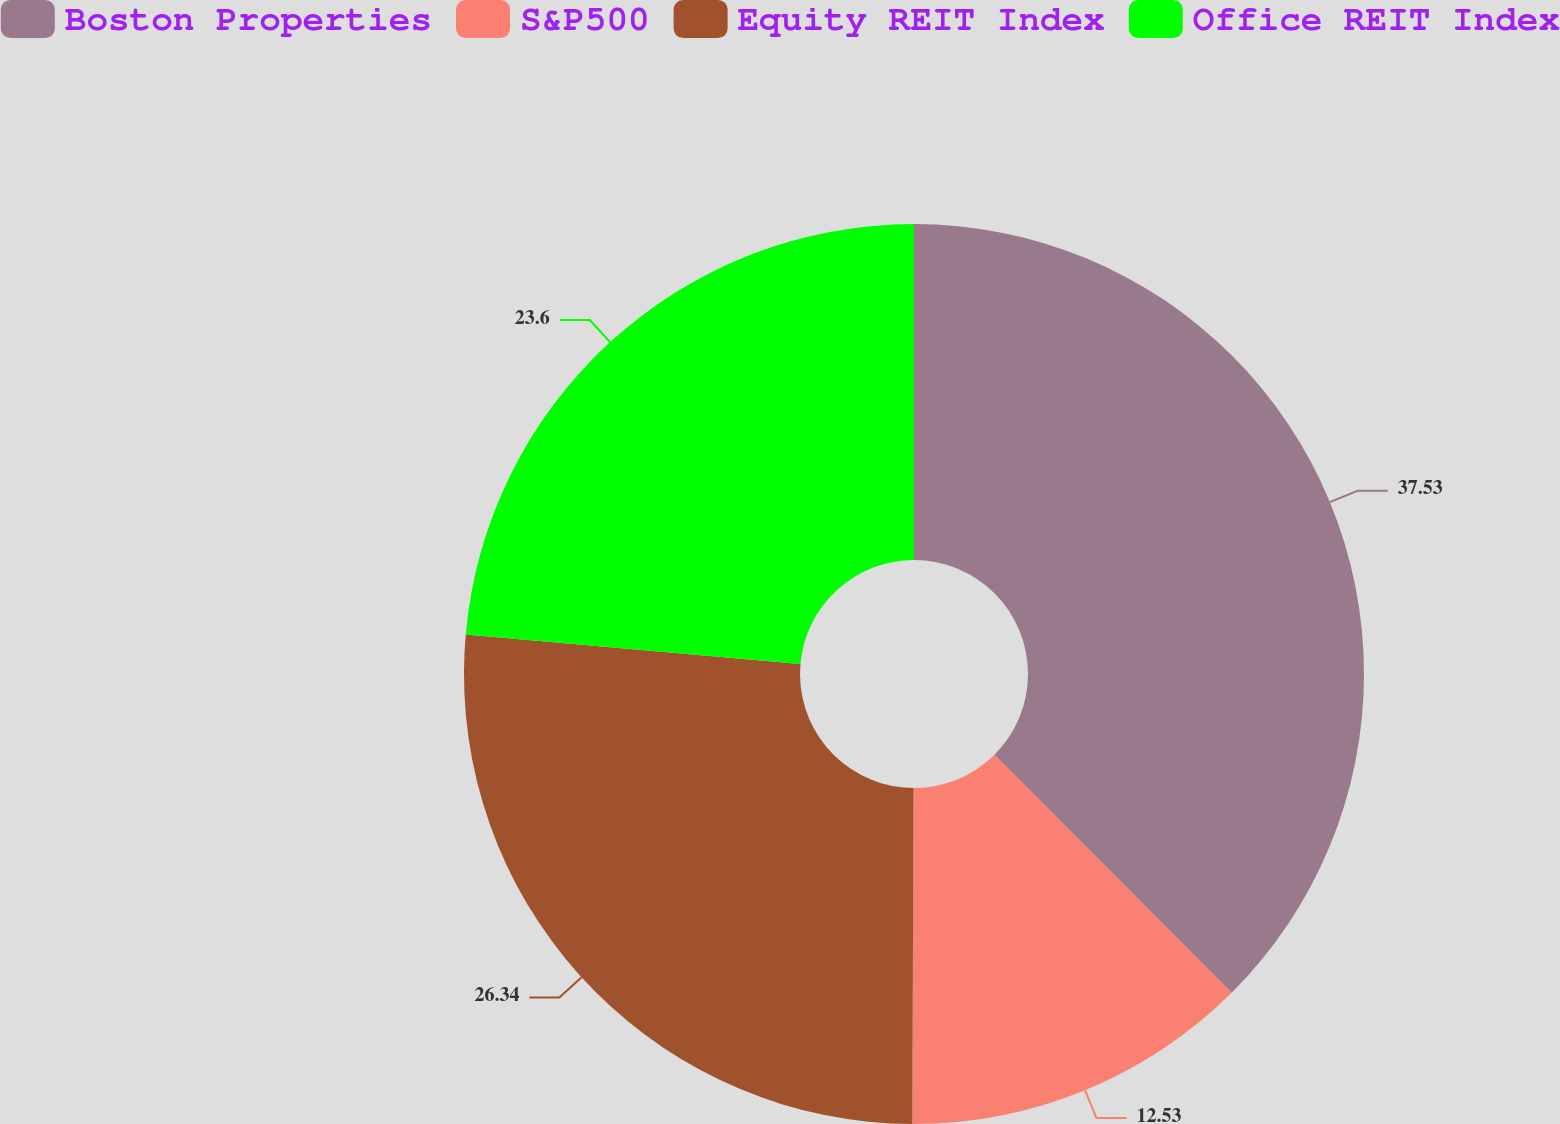Convert chart to OTSL. <chart><loc_0><loc_0><loc_500><loc_500><pie_chart><fcel>Boston Properties<fcel>S&P500<fcel>Equity REIT Index<fcel>Office REIT Index<nl><fcel>37.53%<fcel>12.53%<fcel>26.34%<fcel>23.6%<nl></chart> 